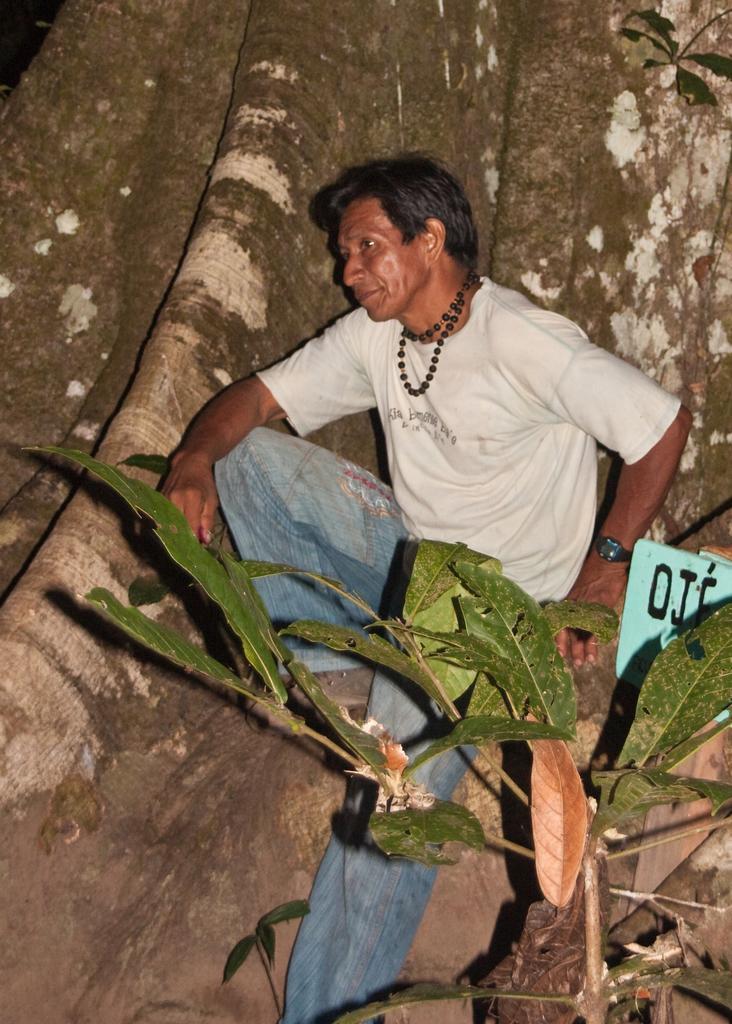Can you describe this image briefly? In the middle of the image, there is a person in white color t-shirt, on a tree. Beside him, there is a tree which is having green color leaves. 